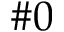Convert formula to latex. <formula><loc_0><loc_0><loc_500><loc_500>\# 0</formula> 